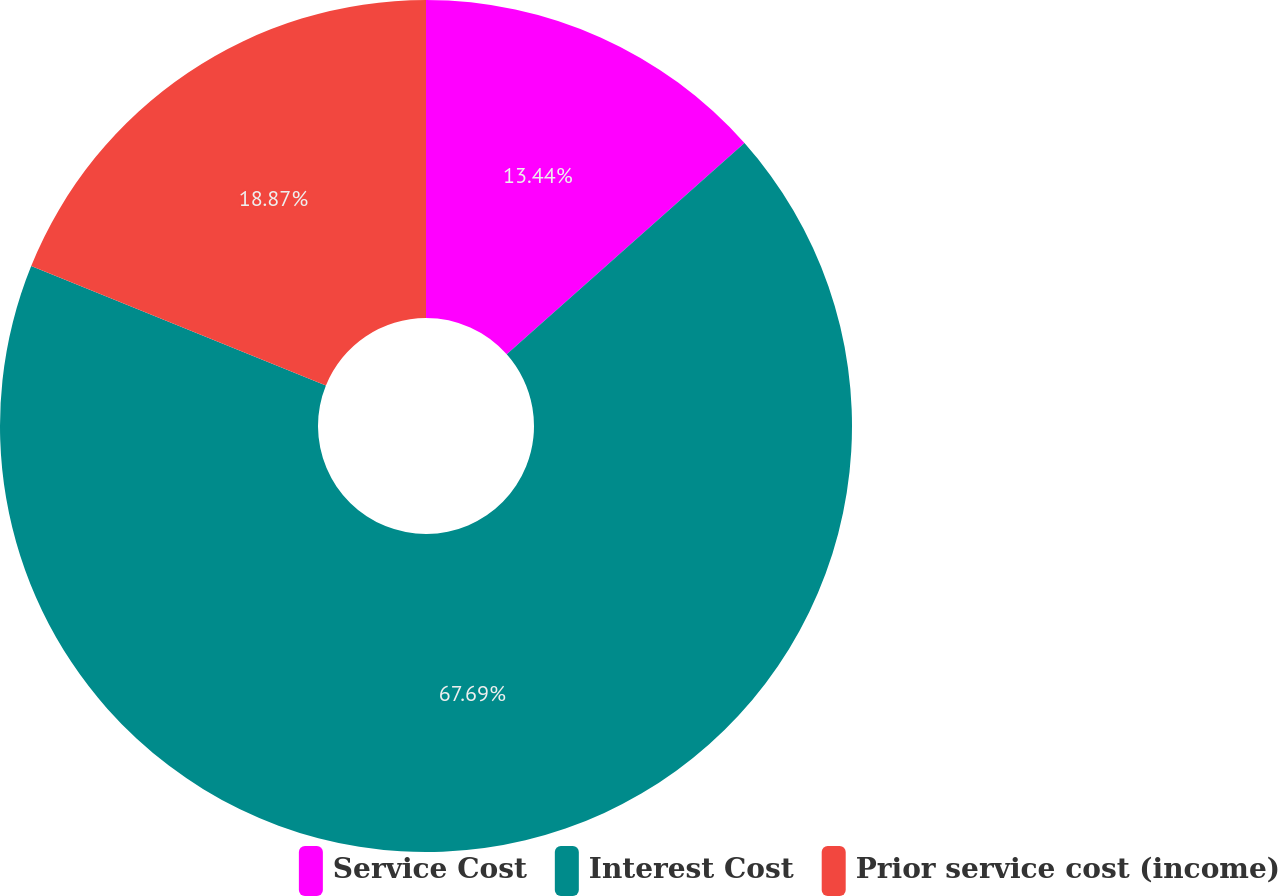Convert chart. <chart><loc_0><loc_0><loc_500><loc_500><pie_chart><fcel>Service Cost<fcel>Interest Cost<fcel>Prior service cost (income)<nl><fcel>13.44%<fcel>67.69%<fcel>18.87%<nl></chart> 